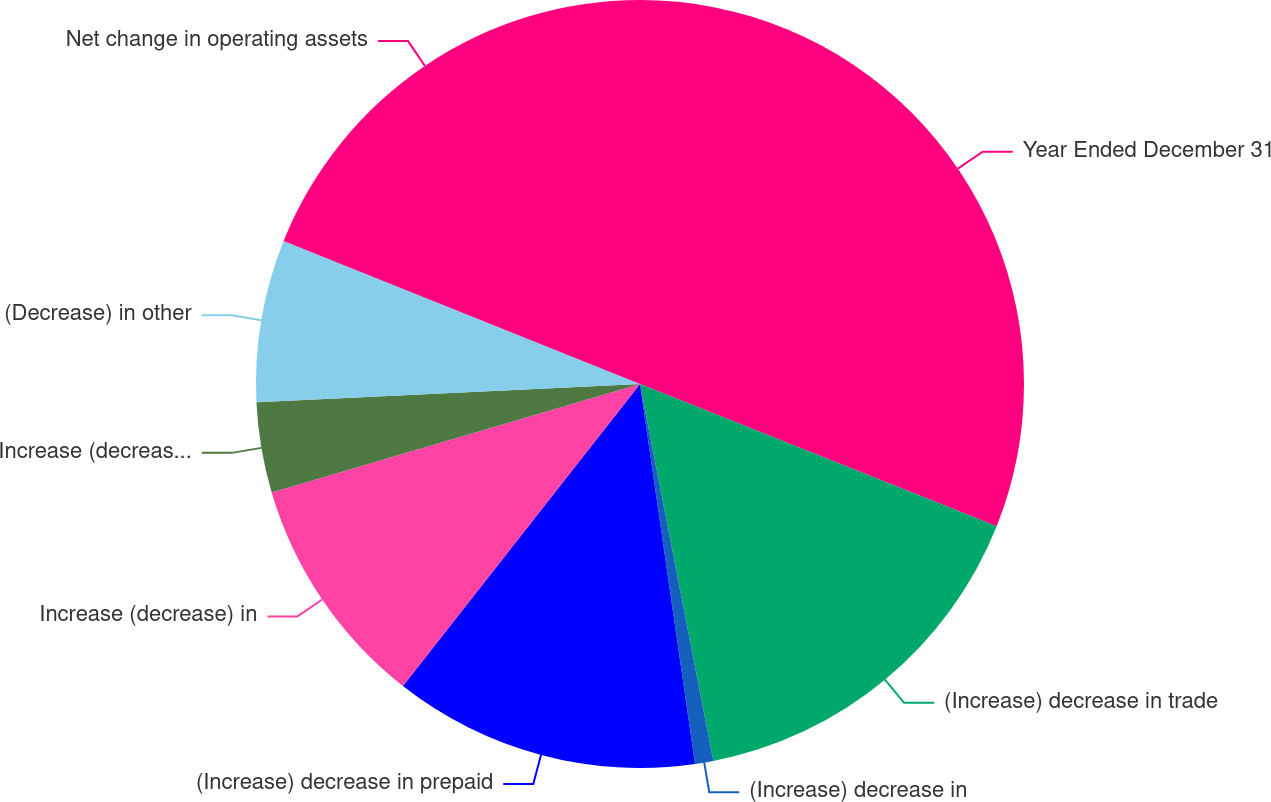Convert chart. <chart><loc_0><loc_0><loc_500><loc_500><pie_chart><fcel>Year Ended December 31<fcel>(Increase) decrease in trade<fcel>(Increase) decrease in<fcel>(Increase) decrease in prepaid<fcel>Increase (decrease) in<fcel>Increase (decrease) in accrued<fcel>(Decrease) in other<fcel>Net change in operating assets<nl><fcel>31.04%<fcel>15.9%<fcel>0.77%<fcel>12.88%<fcel>9.85%<fcel>3.8%<fcel>6.83%<fcel>18.93%<nl></chart> 